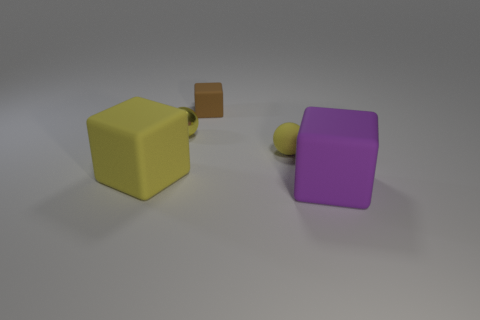Add 4 small purple shiny cylinders. How many objects exist? 9 Subtract all cubes. How many objects are left? 2 Subtract all large purple metal things. Subtract all spheres. How many objects are left? 3 Add 2 yellow matte balls. How many yellow matte balls are left? 3 Add 4 large rubber cubes. How many large rubber cubes exist? 6 Subtract 0 purple balls. How many objects are left? 5 